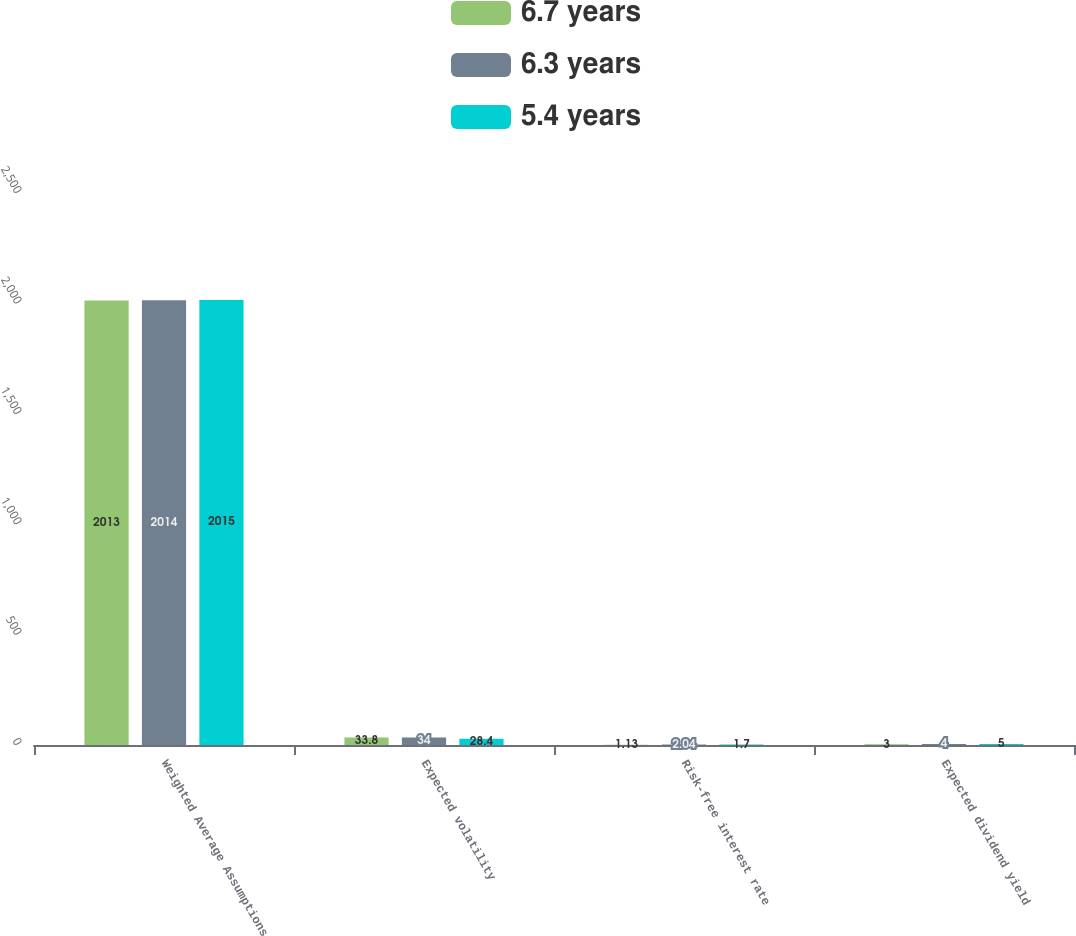<chart> <loc_0><loc_0><loc_500><loc_500><stacked_bar_chart><ecel><fcel>Weighted Average Assumptions<fcel>Expected volatility<fcel>Risk-free interest rate<fcel>Expected dividend yield<nl><fcel>6.7 years<fcel>2013<fcel>33.8<fcel>1.13<fcel>3<nl><fcel>6.3 years<fcel>2014<fcel>34<fcel>2.04<fcel>4<nl><fcel>5.4 years<fcel>2015<fcel>28.4<fcel>1.7<fcel>5<nl></chart> 